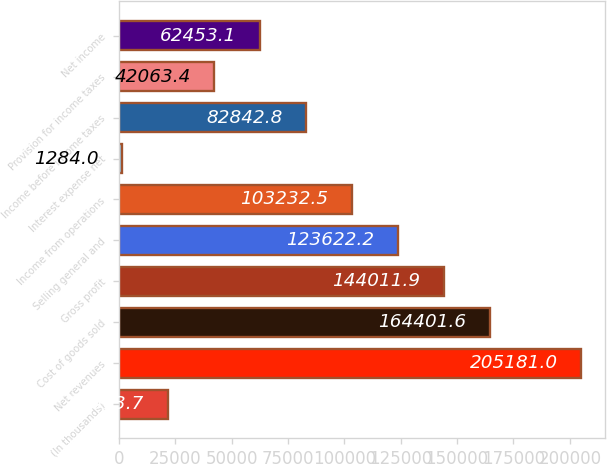<chart> <loc_0><loc_0><loc_500><loc_500><bar_chart><fcel>(In thousands)<fcel>Net revenues<fcel>Cost of goods sold<fcel>Gross profit<fcel>Selling general and<fcel>Income from operations<fcel>Interest expense net<fcel>Income before income taxes<fcel>Provision for income taxes<fcel>Net income<nl><fcel>21673.7<fcel>205181<fcel>164402<fcel>144012<fcel>123622<fcel>103232<fcel>1284<fcel>82842.8<fcel>42063.4<fcel>62453.1<nl></chart> 